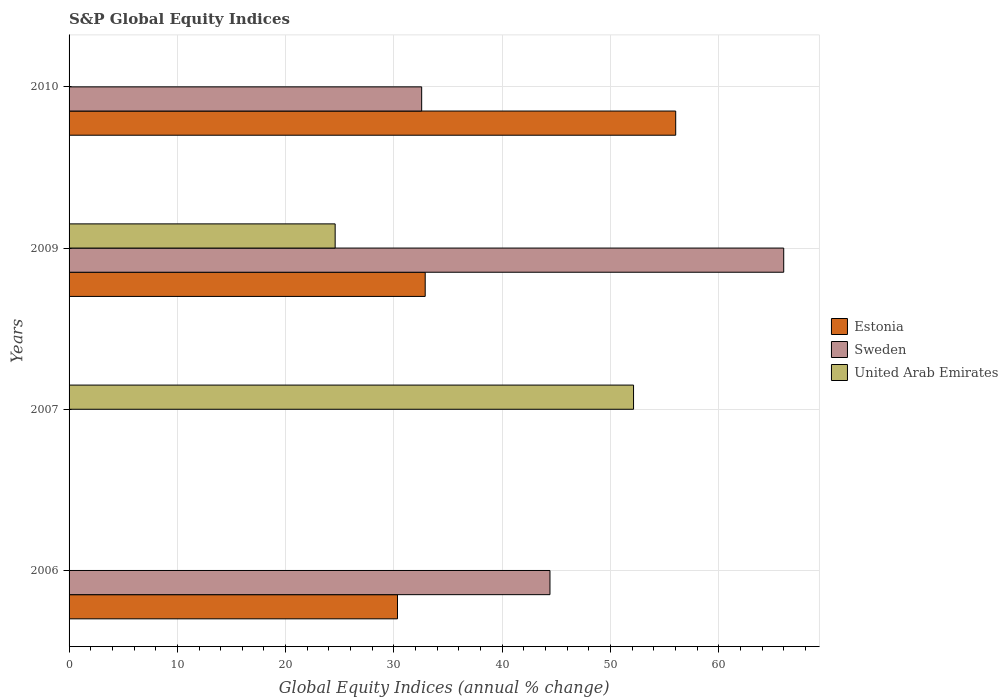Are the number of bars on each tick of the Y-axis equal?
Make the answer very short. No. How many bars are there on the 1st tick from the top?
Your answer should be very brief. 2. In how many cases, is the number of bars for a given year not equal to the number of legend labels?
Your answer should be compact. 3. Across all years, what is the maximum global equity indices in Sweden?
Provide a succinct answer. 66. Across all years, what is the minimum global equity indices in Estonia?
Make the answer very short. 0. What is the total global equity indices in Estonia in the graph?
Ensure brevity in your answer.  119.24. What is the difference between the global equity indices in United Arab Emirates in 2009 and the global equity indices in Sweden in 2007?
Give a very brief answer. 24.57. What is the average global equity indices in Sweden per year?
Give a very brief answer. 35.74. In the year 2009, what is the difference between the global equity indices in United Arab Emirates and global equity indices in Estonia?
Your answer should be very brief. -8.32. In how many years, is the global equity indices in Estonia greater than 54 %?
Provide a succinct answer. 1. What is the ratio of the global equity indices in Sweden in 2006 to that in 2010?
Make the answer very short. 1.36. What is the difference between the highest and the second highest global equity indices in Sweden?
Your response must be concise. 21.59. What is the difference between the highest and the lowest global equity indices in United Arab Emirates?
Offer a very short reply. 52.13. Are all the bars in the graph horizontal?
Provide a succinct answer. Yes. What is the difference between two consecutive major ticks on the X-axis?
Your response must be concise. 10. Are the values on the major ticks of X-axis written in scientific E-notation?
Keep it short and to the point. No. Does the graph contain any zero values?
Give a very brief answer. Yes. What is the title of the graph?
Offer a terse response. S&P Global Equity Indices. What is the label or title of the X-axis?
Give a very brief answer. Global Equity Indices (annual % change). What is the Global Equity Indices (annual % change) of Estonia in 2006?
Your answer should be very brief. 30.33. What is the Global Equity Indices (annual % change) of Sweden in 2006?
Provide a short and direct response. 44.41. What is the Global Equity Indices (annual % change) of United Arab Emirates in 2006?
Give a very brief answer. 0. What is the Global Equity Indices (annual % change) of Sweden in 2007?
Offer a terse response. 0. What is the Global Equity Indices (annual % change) of United Arab Emirates in 2007?
Provide a short and direct response. 52.13. What is the Global Equity Indices (annual % change) in Estonia in 2009?
Make the answer very short. 32.89. What is the Global Equity Indices (annual % change) of Sweden in 2009?
Ensure brevity in your answer.  66. What is the Global Equity Indices (annual % change) of United Arab Emirates in 2009?
Provide a short and direct response. 24.57. What is the Global Equity Indices (annual % change) in Estonia in 2010?
Provide a short and direct response. 56.03. What is the Global Equity Indices (annual % change) of Sweden in 2010?
Your answer should be very brief. 32.56. Across all years, what is the maximum Global Equity Indices (annual % change) of Estonia?
Give a very brief answer. 56.03. Across all years, what is the maximum Global Equity Indices (annual % change) in Sweden?
Give a very brief answer. 66. Across all years, what is the maximum Global Equity Indices (annual % change) of United Arab Emirates?
Make the answer very short. 52.13. Across all years, what is the minimum Global Equity Indices (annual % change) in Estonia?
Ensure brevity in your answer.  0. Across all years, what is the minimum Global Equity Indices (annual % change) in Sweden?
Give a very brief answer. 0. What is the total Global Equity Indices (annual % change) in Estonia in the graph?
Your response must be concise. 119.25. What is the total Global Equity Indices (annual % change) in Sweden in the graph?
Offer a terse response. 142.98. What is the total Global Equity Indices (annual % change) in United Arab Emirates in the graph?
Offer a very short reply. 76.71. What is the difference between the Global Equity Indices (annual % change) in Estonia in 2006 and that in 2009?
Offer a very short reply. -2.56. What is the difference between the Global Equity Indices (annual % change) of Sweden in 2006 and that in 2009?
Your answer should be very brief. -21.59. What is the difference between the Global Equity Indices (annual % change) of Estonia in 2006 and that in 2010?
Ensure brevity in your answer.  -25.7. What is the difference between the Global Equity Indices (annual % change) of Sweden in 2006 and that in 2010?
Provide a short and direct response. 11.85. What is the difference between the Global Equity Indices (annual % change) in United Arab Emirates in 2007 and that in 2009?
Give a very brief answer. 27.56. What is the difference between the Global Equity Indices (annual % change) in Estonia in 2009 and that in 2010?
Your response must be concise. -23.14. What is the difference between the Global Equity Indices (annual % change) of Sweden in 2009 and that in 2010?
Ensure brevity in your answer.  33.44. What is the difference between the Global Equity Indices (annual % change) in Estonia in 2006 and the Global Equity Indices (annual % change) in United Arab Emirates in 2007?
Offer a very short reply. -21.8. What is the difference between the Global Equity Indices (annual % change) in Sweden in 2006 and the Global Equity Indices (annual % change) in United Arab Emirates in 2007?
Your response must be concise. -7.72. What is the difference between the Global Equity Indices (annual % change) in Estonia in 2006 and the Global Equity Indices (annual % change) in Sweden in 2009?
Keep it short and to the point. -35.67. What is the difference between the Global Equity Indices (annual % change) of Estonia in 2006 and the Global Equity Indices (annual % change) of United Arab Emirates in 2009?
Keep it short and to the point. 5.76. What is the difference between the Global Equity Indices (annual % change) of Sweden in 2006 and the Global Equity Indices (annual % change) of United Arab Emirates in 2009?
Give a very brief answer. 19.84. What is the difference between the Global Equity Indices (annual % change) in Estonia in 2006 and the Global Equity Indices (annual % change) in Sweden in 2010?
Provide a short and direct response. -2.23. What is the difference between the Global Equity Indices (annual % change) of Estonia in 2009 and the Global Equity Indices (annual % change) of Sweden in 2010?
Ensure brevity in your answer.  0.33. What is the average Global Equity Indices (annual % change) of Estonia per year?
Offer a terse response. 29.81. What is the average Global Equity Indices (annual % change) in Sweden per year?
Give a very brief answer. 35.74. What is the average Global Equity Indices (annual % change) of United Arab Emirates per year?
Your answer should be compact. 19.18. In the year 2006, what is the difference between the Global Equity Indices (annual % change) of Estonia and Global Equity Indices (annual % change) of Sweden?
Keep it short and to the point. -14.08. In the year 2009, what is the difference between the Global Equity Indices (annual % change) of Estonia and Global Equity Indices (annual % change) of Sweden?
Keep it short and to the point. -33.11. In the year 2009, what is the difference between the Global Equity Indices (annual % change) of Estonia and Global Equity Indices (annual % change) of United Arab Emirates?
Your answer should be compact. 8.32. In the year 2009, what is the difference between the Global Equity Indices (annual % change) in Sweden and Global Equity Indices (annual % change) in United Arab Emirates?
Give a very brief answer. 41.43. In the year 2010, what is the difference between the Global Equity Indices (annual % change) in Estonia and Global Equity Indices (annual % change) in Sweden?
Your answer should be very brief. 23.46. What is the ratio of the Global Equity Indices (annual % change) of Estonia in 2006 to that in 2009?
Keep it short and to the point. 0.92. What is the ratio of the Global Equity Indices (annual % change) of Sweden in 2006 to that in 2009?
Your answer should be compact. 0.67. What is the ratio of the Global Equity Indices (annual % change) in Estonia in 2006 to that in 2010?
Give a very brief answer. 0.54. What is the ratio of the Global Equity Indices (annual % change) of Sweden in 2006 to that in 2010?
Your answer should be very brief. 1.36. What is the ratio of the Global Equity Indices (annual % change) of United Arab Emirates in 2007 to that in 2009?
Offer a terse response. 2.12. What is the ratio of the Global Equity Indices (annual % change) in Estonia in 2009 to that in 2010?
Provide a short and direct response. 0.59. What is the ratio of the Global Equity Indices (annual % change) in Sweden in 2009 to that in 2010?
Your answer should be compact. 2.03. What is the difference between the highest and the second highest Global Equity Indices (annual % change) of Estonia?
Make the answer very short. 23.14. What is the difference between the highest and the second highest Global Equity Indices (annual % change) in Sweden?
Your response must be concise. 21.59. What is the difference between the highest and the lowest Global Equity Indices (annual % change) in Estonia?
Keep it short and to the point. 56.03. What is the difference between the highest and the lowest Global Equity Indices (annual % change) in Sweden?
Make the answer very short. 66. What is the difference between the highest and the lowest Global Equity Indices (annual % change) in United Arab Emirates?
Ensure brevity in your answer.  52.13. 